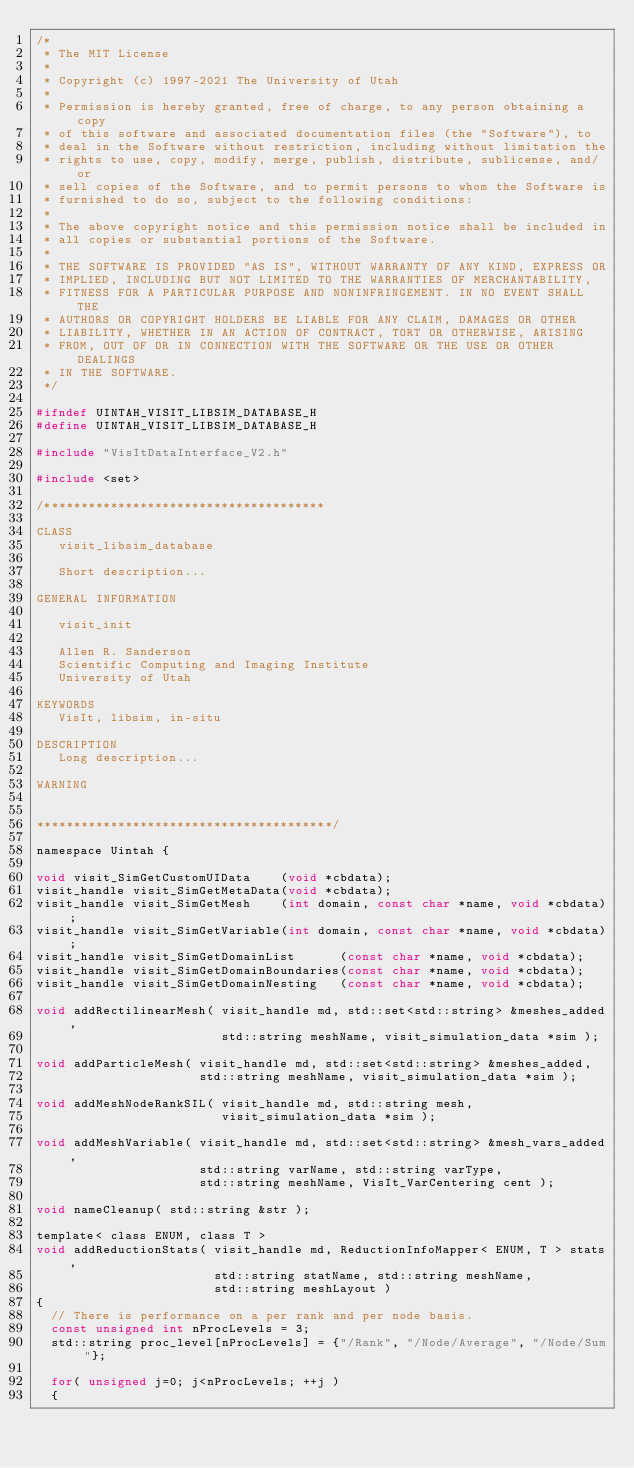<code> <loc_0><loc_0><loc_500><loc_500><_C_>/*
 * The MIT License
 *
 * Copyright (c) 1997-2021 The University of Utah
 *
 * Permission is hereby granted, free of charge, to any person obtaining a copy
 * of this software and associated documentation files (the "Software"), to
 * deal in the Software without restriction, including without limitation the
 * rights to use, copy, modify, merge, publish, distribute, sublicense, and/or
 * sell copies of the Software, and to permit persons to whom the Software is
 * furnished to do so, subject to the following conditions:
 *
 * The above copyright notice and this permission notice shall be included in
 * all copies or substantial portions of the Software.
 *
 * THE SOFTWARE IS PROVIDED "AS IS", WITHOUT WARRANTY OF ANY KIND, EXPRESS OR
 * IMPLIED, INCLUDING BUT NOT LIMITED TO THE WARRANTIES OF MERCHANTABILITY,
 * FITNESS FOR A PARTICULAR PURPOSE AND NONINFRINGEMENT. IN NO EVENT SHALL THE
 * AUTHORS OR COPYRIGHT HOLDERS BE LIABLE FOR ANY CLAIM, DAMAGES OR OTHER
 * LIABILITY, WHETHER IN AN ACTION OF CONTRACT, TORT OR OTHERWISE, ARISING
 * FROM, OUT OF OR IN CONNECTION WITH THE SOFTWARE OR THE USE OR OTHER DEALINGS
 * IN THE SOFTWARE.
 */

#ifndef UINTAH_VISIT_LIBSIM_DATABASE_H
#define UINTAH_VISIT_LIBSIM_DATABASE_H

#include "VisItDataInterface_V2.h"

#include <set>

/**************************************
        
CLASS
   visit_libsim_database
        
   Short description...
        
GENERAL INFORMATION
        
   visit_init
        
   Allen R. Sanderson
   Scientific Computing and Imaging Institute
   University of Utah
        
KEYWORDS
   VisIt, libsim, in-situ
        
DESCRIPTION
   Long description...
        
WARNING
        

****************************************/

namespace Uintah {

void visit_SimGetCustomUIData    (void *cbdata);
visit_handle visit_SimGetMetaData(void *cbdata);
visit_handle visit_SimGetMesh    (int domain, const char *name, void *cbdata);
visit_handle visit_SimGetVariable(int domain, const char *name, void *cbdata);
visit_handle visit_SimGetDomainList      (const char *name, void *cbdata);
visit_handle visit_SimGetDomainBoundaries(const char *name, void *cbdata);
visit_handle visit_SimGetDomainNesting   (const char *name, void *cbdata);

void addRectilinearMesh( visit_handle md, std::set<std::string> &meshes_added,
                         std::string meshName, visit_simulation_data *sim );

void addParticleMesh( visit_handle md, std::set<std::string> &meshes_added,
                      std::string meshName, visit_simulation_data *sim );

void addMeshNodeRankSIL( visit_handle md, std::string mesh,
                         visit_simulation_data *sim );
  
void addMeshVariable( visit_handle md, std::set<std::string> &mesh_vars_added,
                      std::string varName, std::string varType,
                      std::string meshName, VisIt_VarCentering cent );

void nameCleanup( std::string &str );
  
template< class ENUM, class T >
void addReductionStats( visit_handle md, ReductionInfoMapper< ENUM, T > stats,
                        std::string statName, std::string meshName,
                        std::string meshLayout )
{
  // There is performance on a per rank and per node basis.
  const unsigned int nProcLevels = 3;
  std::string proc_level[nProcLevels] = {"/Rank", "/Node/Average", "/Node/Sum"};

  for( unsigned j=0; j<nProcLevels; ++j )
  {</code> 